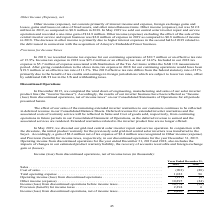According to Advanced Energy's financial document, What will the results of the company's inverter business reflect as in their Consolidated Statements of Operations? Income (loss) from discontinued operations, net of income taxes. The document states: "of our inverter business have been reflected as “Income (loss) from discontinued operations, net of income taxes” on our Consolidated Statements of Op..." Also, What was the total Income (loss) from discontinued operations, net of income taxes in 2019? According to the financial document, 8,480 (in thousands). The relevant text states: "discontinued operations, net of income taxes . $ 8,480 $ (38)..." Also, What was the total operating expense in 2018? According to the financial document, 96 (in thousands). The relevant text states: "ales . (901) (88) Total operating expense . 1,022 96 Operating income (loss) from discontinued operations . (121) (8)..." Also, can you calculate: What was the change in total operating expense between 2018 and 2019? Based on the calculation: 1,022-96, the result is 926 (in thousands). This is based on the information: "ales . (901) (88) Total operating expense . 1,022 96 Operating income (loss) from discontinued operations . (121) (8) t of sales . (901) (88) Total operating expense . 1,022 96 Operating income (loss)..." The key data points involved are: 1,022, 96. Also, can you calculate: What was the change in Provision (benefit) for income taxes between 2018 and 2019? Based on the calculation: 2,294-6, the result is 2288 (in thousands). This is based on the information: "Provision (benefit) for income taxes . 2,294 6 Income (loss) from discontinued operations, net of income taxes . $ 8,480 $ (38) Provision (benefit) for income taxes . 2,294 6 Income (loss) from discon..." The key data points involved are: 2,294, 6. Also, can you calculate: What was the percentage change in total operating expense between 2018 and 2019? To answer this question, I need to perform calculations using the financial data. The calculation is: (1,022-96)/96, which equals 964.58 (percentage). This is based on the information: "ales . (901) (88) Total operating expense . 1,022 96 Operating income (loss) from discontinued operations . (121) (8) t of sales . (901) (88) Total operating expense . 1,022 96 Operating income (loss)..." The key data points involved are: 1,022. 